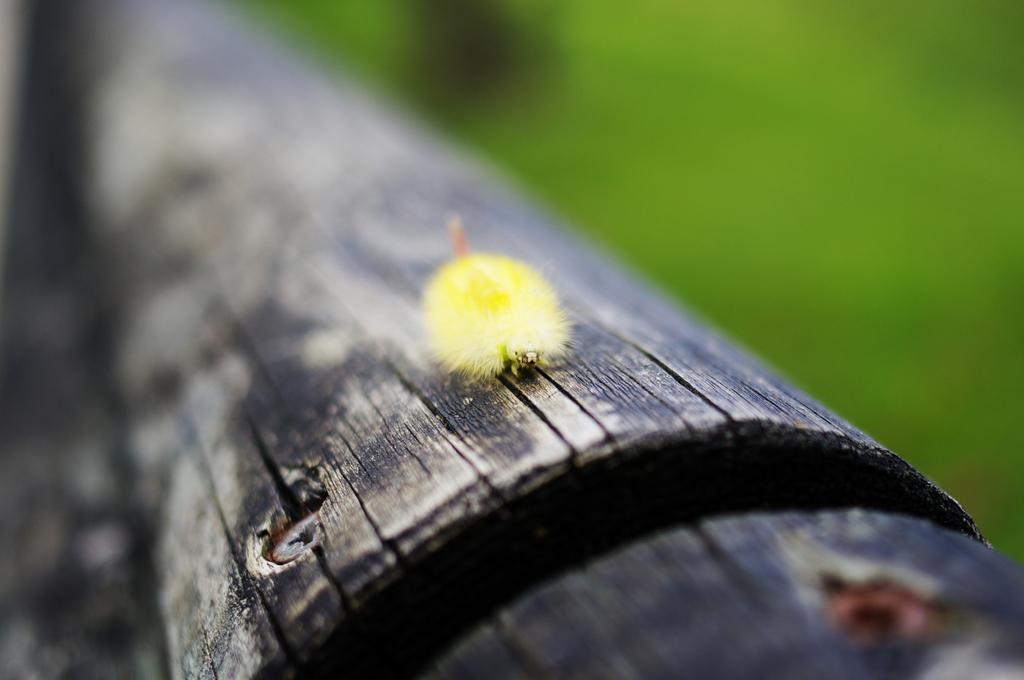Please provide a concise description of this image. In the middle of the image there is an insect on a stem. 